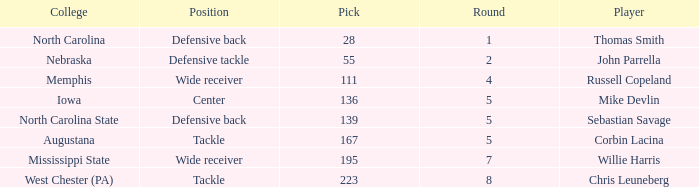What is the sum of Round with a Pick that is 55? 2.0. 